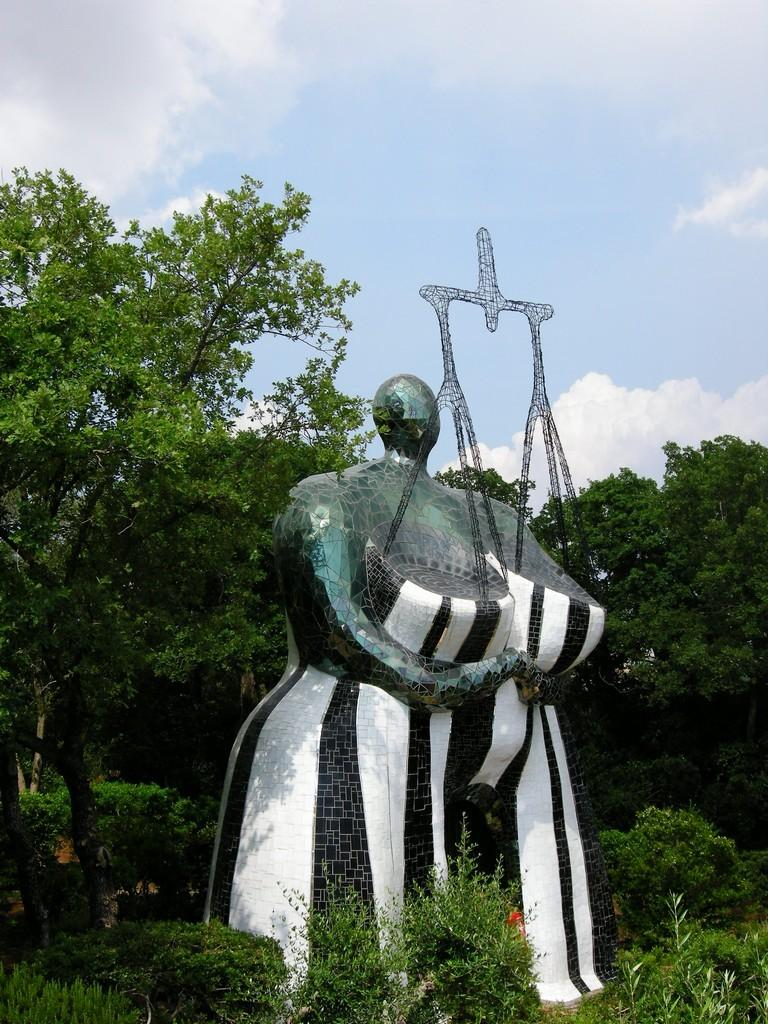What is the main subject in the picture? There is a statue in the picture. What type of natural elements can be seen in the picture? There are trees and plants in the picture. How would you describe the sky in the picture? The sky is blue and cloudy. What type of crown is the statue wearing in the picture? There is no crown present on the statue in the picture. Can you see a baseball game happening in the background of the picture? There is no baseball game or any reference to sports in the picture. 